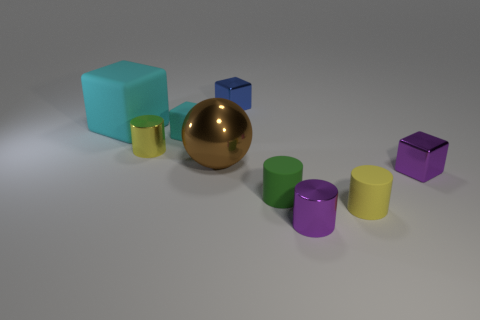Is there any other thing that is the same shape as the big brown metal object?
Provide a short and direct response. No. How many objects are either small things or big green spheres?
Offer a very short reply. 7. The other shiny cylinder that is the same size as the purple cylinder is what color?
Ensure brevity in your answer.  Yellow. How many objects are either tiny yellow things that are behind the brown ball or large cyan matte objects?
Provide a succinct answer. 2. How many other objects are there of the same size as the green rubber cylinder?
Your answer should be very brief. 6. There is a cylinder that is left of the tiny green thing; what is its size?
Offer a very short reply. Small. What is the shape of the blue object that is made of the same material as the small purple cylinder?
Your response must be concise. Cube. Is there any other thing of the same color as the tiny matte cube?
Provide a succinct answer. Yes. There is a matte thing to the left of the small cylinder that is on the left side of the tiny blue metal object; what color is it?
Give a very brief answer. Cyan. What number of large things are green matte cylinders or purple metal cylinders?
Provide a short and direct response. 0. 